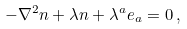<formula> <loc_0><loc_0><loc_500><loc_500>- \nabla ^ { 2 } { n } + \lambda { n } + \lambda ^ { a } { e } _ { a } = 0 \, ,</formula> 